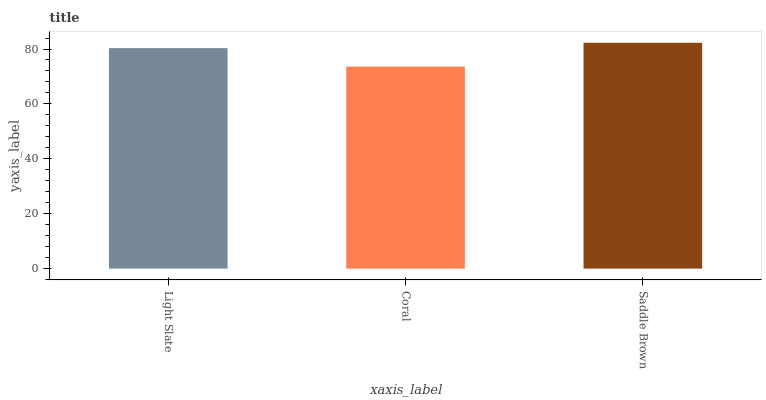Is Coral the minimum?
Answer yes or no. Yes. Is Saddle Brown the maximum?
Answer yes or no. Yes. Is Saddle Brown the minimum?
Answer yes or no. No. Is Coral the maximum?
Answer yes or no. No. Is Saddle Brown greater than Coral?
Answer yes or no. Yes. Is Coral less than Saddle Brown?
Answer yes or no. Yes. Is Coral greater than Saddle Brown?
Answer yes or no. No. Is Saddle Brown less than Coral?
Answer yes or no. No. Is Light Slate the high median?
Answer yes or no. Yes. Is Light Slate the low median?
Answer yes or no. Yes. Is Coral the high median?
Answer yes or no. No. Is Saddle Brown the low median?
Answer yes or no. No. 